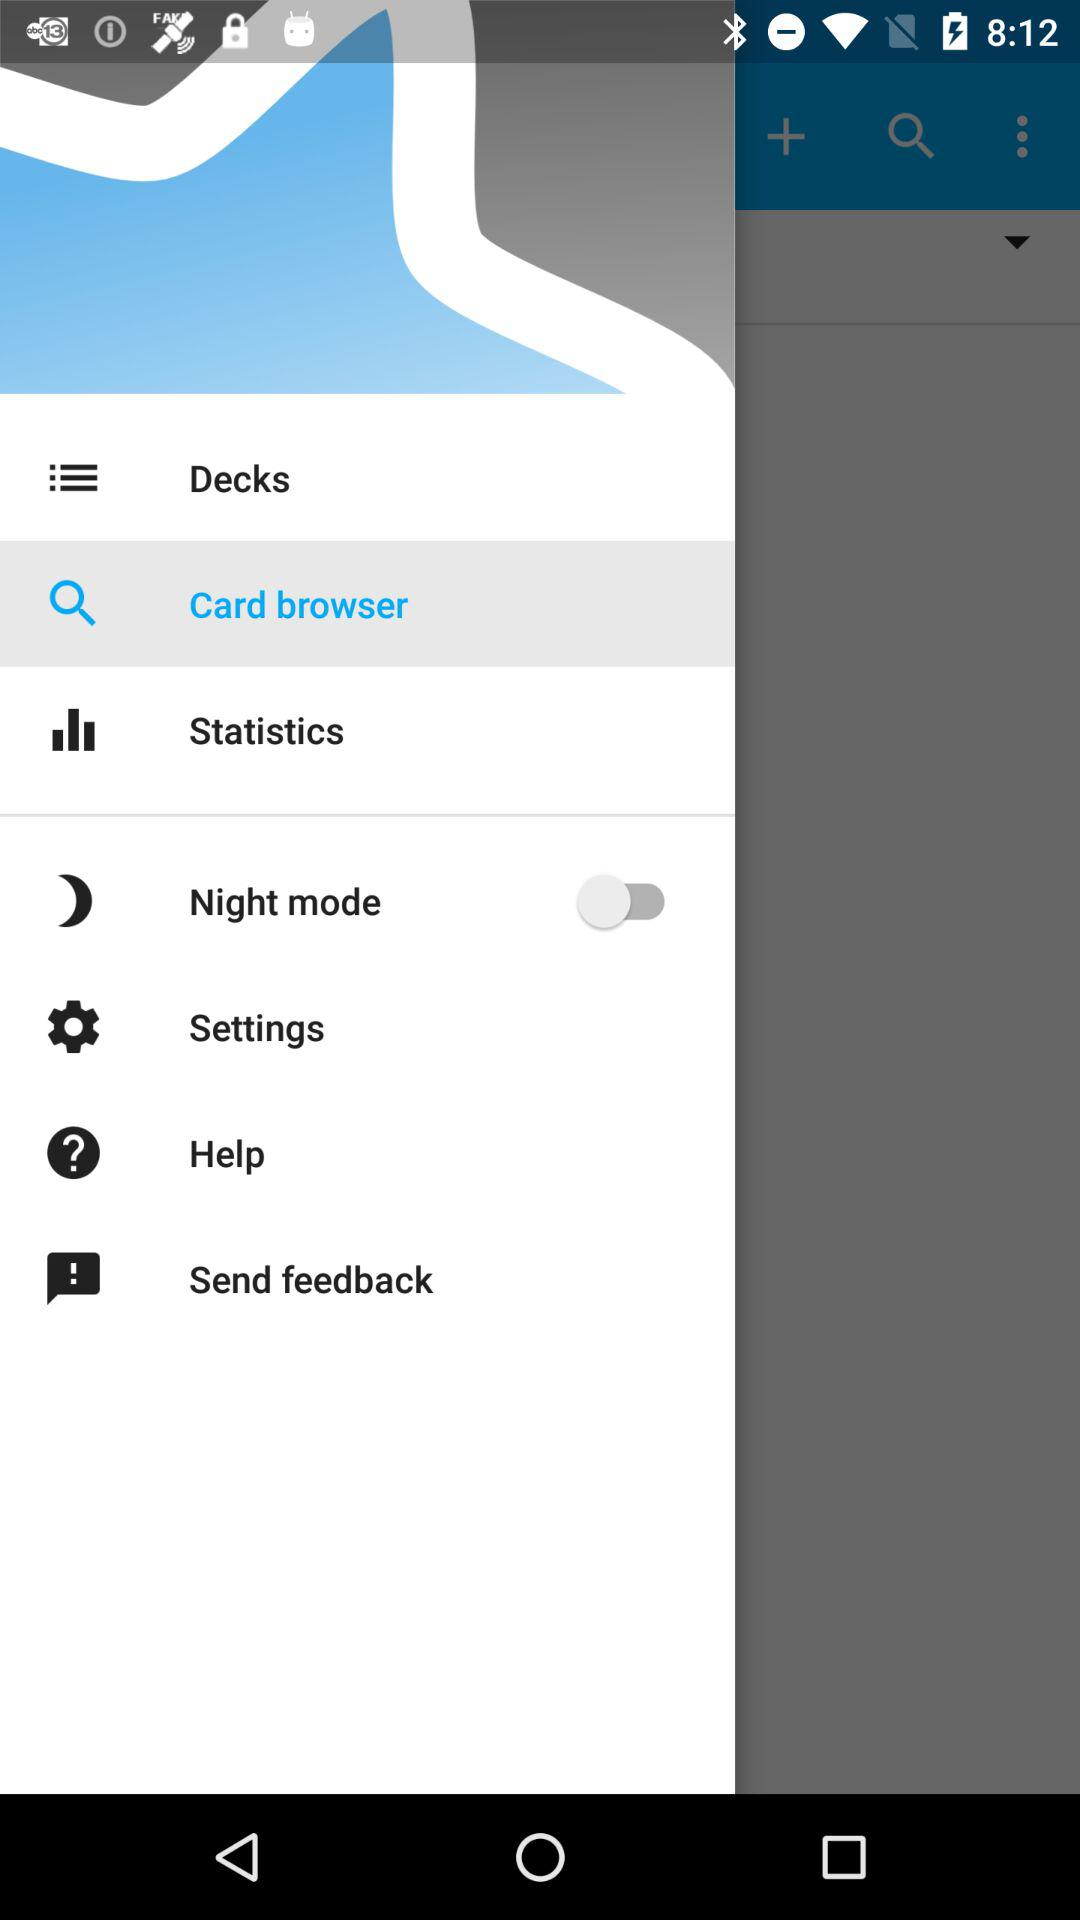What is the selected option? The selected option is "Card browser". 